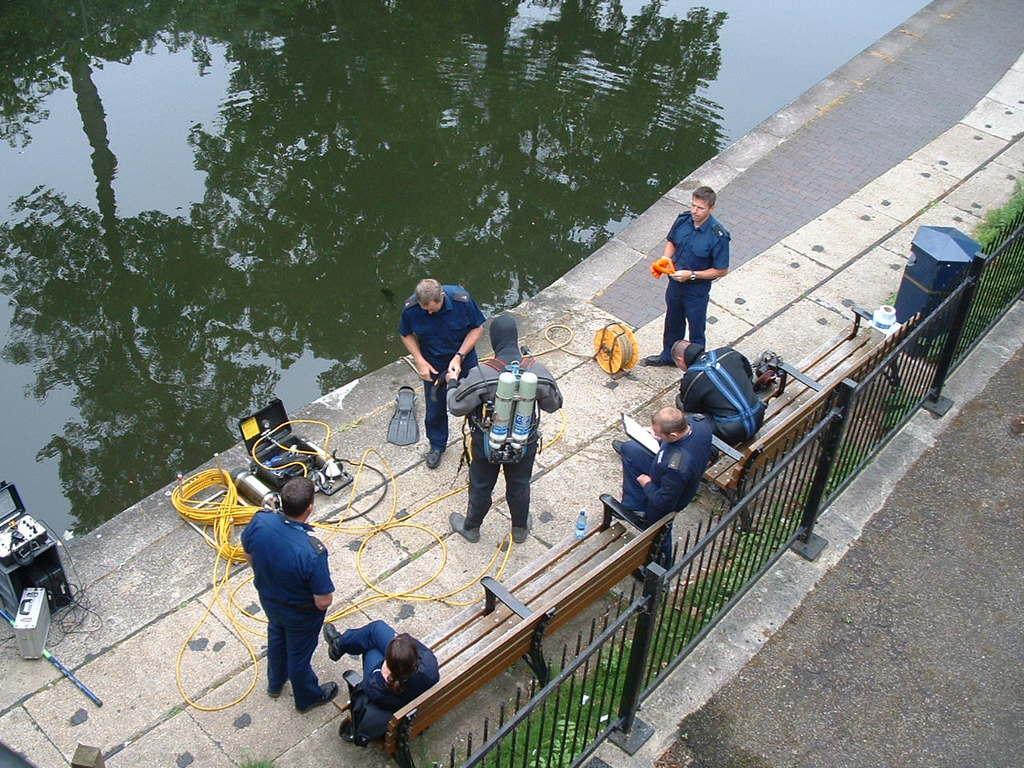In one or two sentences, can you explain what this image depicts? In the image there are few people standing beside a pond with some instruments on the floor and three men sitting on bench in front of fence, there is light reflection of tree in the pond. 